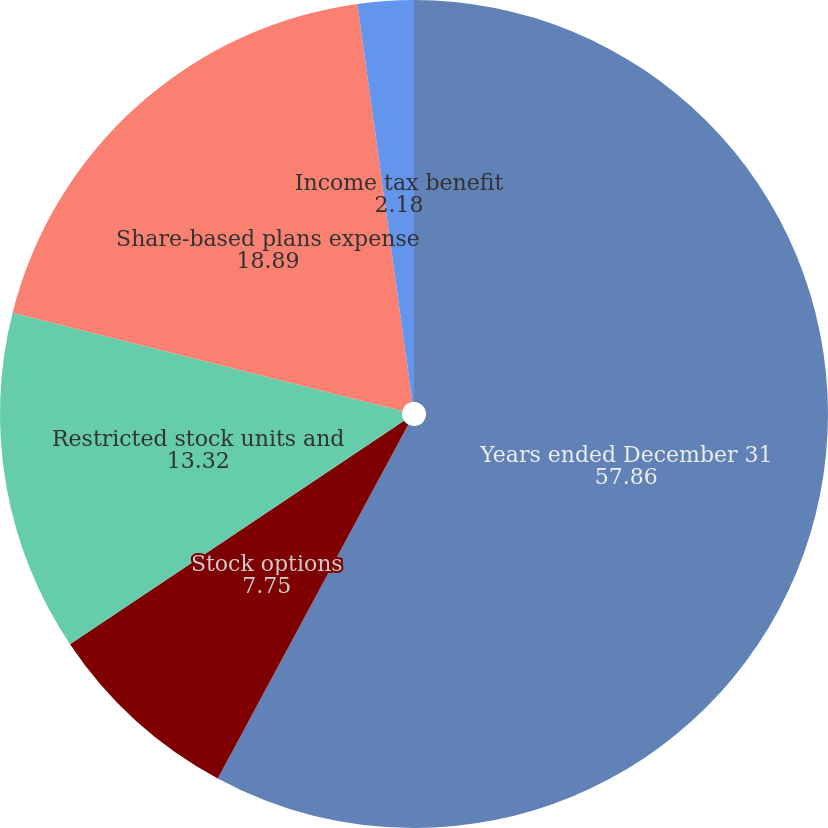Convert chart. <chart><loc_0><loc_0><loc_500><loc_500><pie_chart><fcel>Years ended December 31<fcel>Stock options<fcel>Restricted stock units and<fcel>Share-based plans expense<fcel>Income tax benefit<nl><fcel>57.86%<fcel>7.75%<fcel>13.32%<fcel>18.89%<fcel>2.18%<nl></chart> 